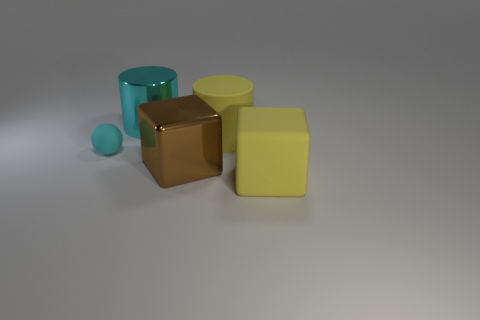Subtract all balls. How many objects are left? 4 Subtract 1 spheres. How many spheres are left? 0 Add 5 tiny cyan spheres. How many objects exist? 10 Subtract all green blocks. Subtract all green balls. How many blocks are left? 2 Subtract all purple balls. How many yellow cubes are left? 1 Subtract all large metallic things. Subtract all large brown objects. How many objects are left? 2 Add 5 shiny cylinders. How many shiny cylinders are left? 6 Add 1 tiny rubber cylinders. How many tiny rubber cylinders exist? 1 Subtract 0 green cylinders. How many objects are left? 5 